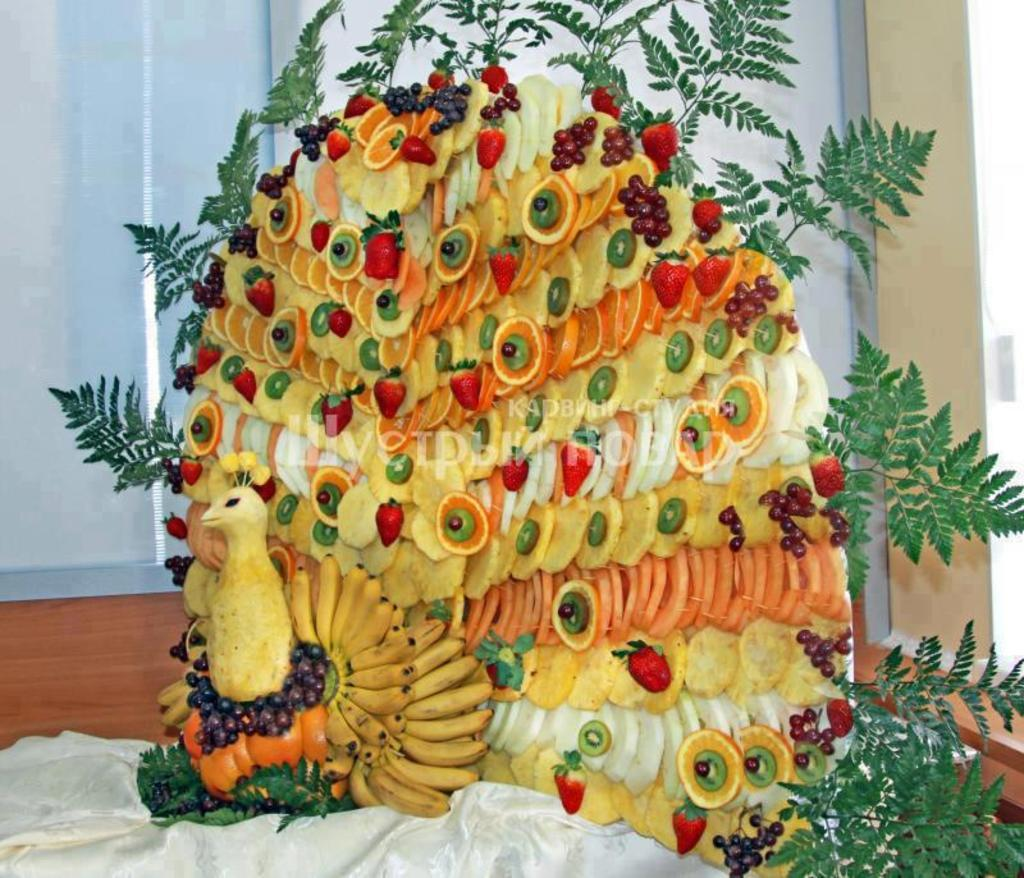What is the main subject of the image? The main subject of the image is a peacock-shaped salad. How is the salad shaped? The salad is shaped like a peacock. What decorative elements are present on the salad? The salad is decorated with green leaves at the top. How many rabbits can be seen in the image? There are no rabbits present in the image. What unit of measurement is used to determine the mass of the salad in the image? The mass of the salad is not mentioned in the image, so it is not possible to determine the unit of measurement used. 